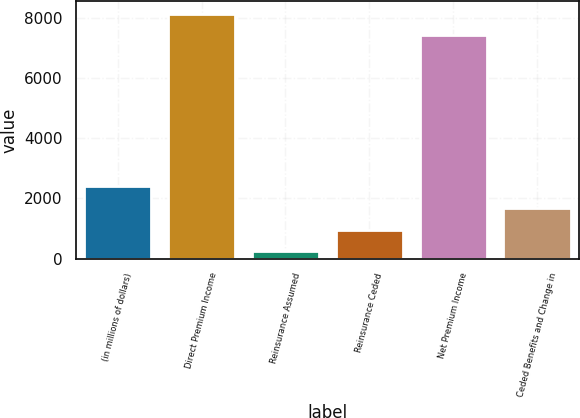Convert chart to OTSL. <chart><loc_0><loc_0><loc_500><loc_500><bar_chart><fcel>(in millions of dollars)<fcel>Direct Premium Income<fcel>Reinsurance Assumed<fcel>Reinsurance Ceded<fcel>Net Premium Income<fcel>Ceded Benefits and Change in<nl><fcel>2399.2<fcel>8150.7<fcel>241.3<fcel>960.6<fcel>7431.4<fcel>1679.9<nl></chart> 